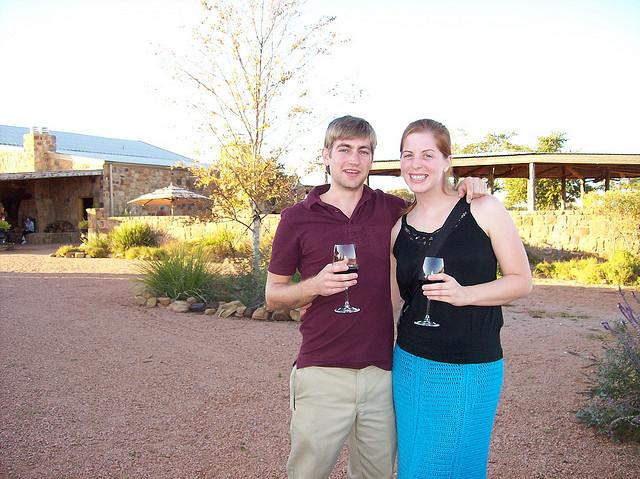What is in their hands?
Answer briefly. Wine glasses. What color is the girl's shirt?
Short answer required. Black. Are these kids at school?
Give a very brief answer. No. What color is the grass?
Concise answer only. Green. What color is the man's shirt?
Give a very brief answer. Maroon. What kind of pattern is on the woman's skirt?
Concise answer only. Words. Does this woman seem to be upset?
Concise answer only. No. What is the man holding?
Short answer required. Wine glass. How old are these kids?
Be succinct. 21. 